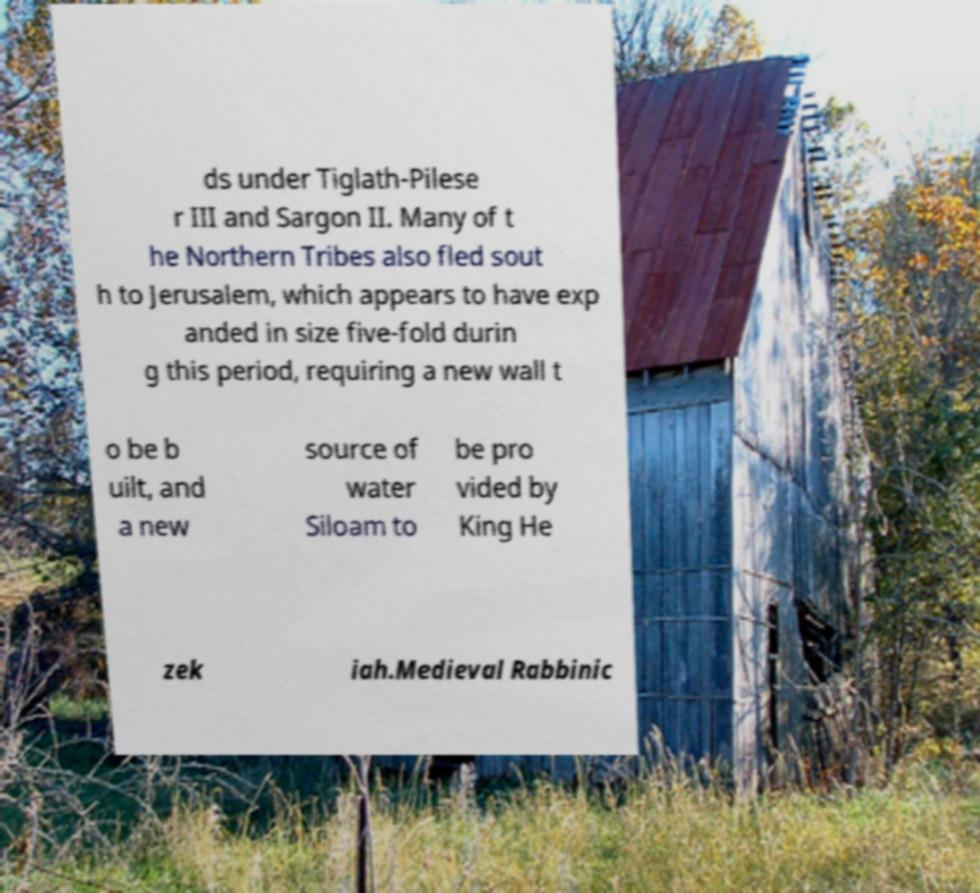Can you accurately transcribe the text from the provided image for me? ds under Tiglath-Pilese r III and Sargon II. Many of t he Northern Tribes also fled sout h to Jerusalem, which appears to have exp anded in size five-fold durin g this period, requiring a new wall t o be b uilt, and a new source of water Siloam to be pro vided by King He zek iah.Medieval Rabbinic 